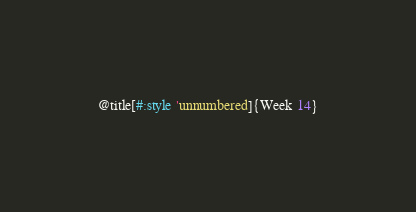<code> <loc_0><loc_0><loc_500><loc_500><_Racket_>@title[#:style 'unnumbered]{Week 14}
</code> 